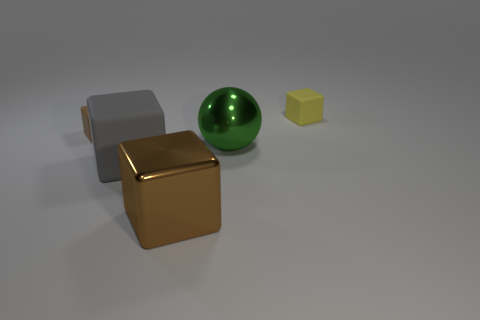What is the shape of the green shiny thing?
Provide a short and direct response. Sphere. Are there the same number of large gray matte objects that are left of the small brown object and tiny purple metallic objects?
Give a very brief answer. Yes. Is there a large ball made of the same material as the tiny brown thing?
Provide a short and direct response. No. Does the tiny matte thing right of the big matte thing have the same shape as the brown thing behind the big shiny block?
Keep it short and to the point. Yes. Is there a green thing?
Make the answer very short. Yes. There is another metallic object that is the same size as the green object; what is its color?
Keep it short and to the point. Brown. How many other large things have the same shape as the brown metal thing?
Give a very brief answer. 1. Do the tiny block on the left side of the green sphere and the yellow object have the same material?
Make the answer very short. Yes. What number of balls are either big gray metallic things or yellow matte objects?
Offer a terse response. 0. There is a big green shiny object right of the brown thing right of the tiny block in front of the yellow rubber object; what shape is it?
Provide a succinct answer. Sphere. 